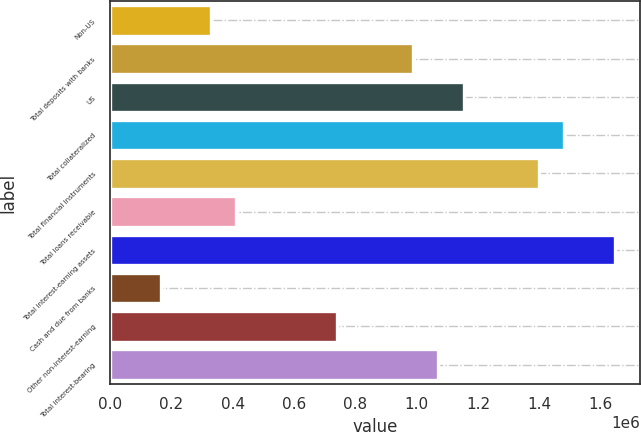Convert chart. <chart><loc_0><loc_0><loc_500><loc_500><bar_chart><fcel>Non-US<fcel>Total deposits with banks<fcel>US<fcel>Total collateralized<fcel>Total financial instruments<fcel>Total loans receivable<fcel>Total interest-earning assets<fcel>Cash and due from banks<fcel>Other non-interest-earning<fcel>Total interest-bearing<nl><fcel>329483<fcel>988366<fcel>1.15309e+06<fcel>1.48253e+06<fcel>1.40017e+06<fcel>411843<fcel>1.64725e+06<fcel>164762<fcel>741285<fcel>1.07073e+06<nl></chart> 